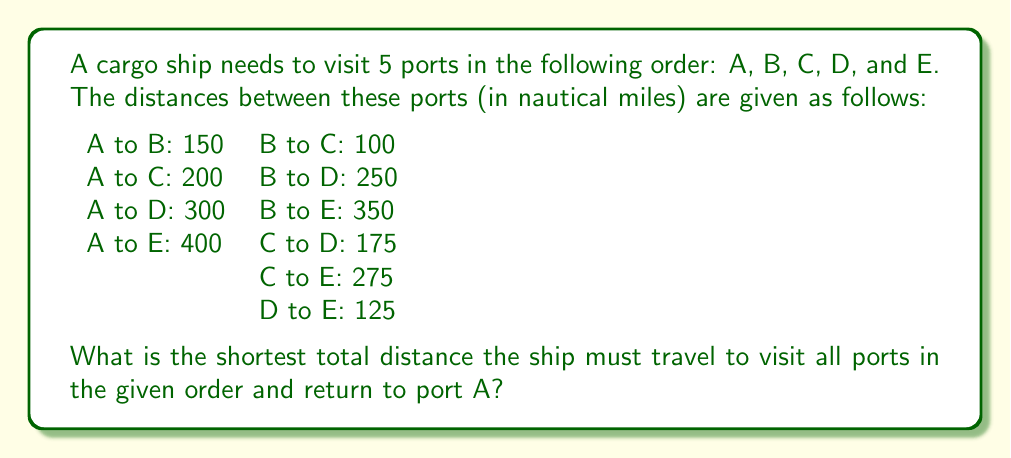Could you help me with this problem? To solve this problem, we need to calculate the total distance of the path A → B → C → D → E → A. Let's break it down step-by-step:

1. Distance from A to B: 150 nautical miles
2. Distance from B to C: 100 nautical miles
3. Distance from C to D: 175 nautical miles
4. Distance from D to E: 125 nautical miles
5. Distance from E back to A: 400 nautical miles

Now, let's sum up these distances:

$$\text{Total Distance} = AB + BC + CD + DE + EA$$
$$\text{Total Distance} = 150 + 100 + 175 + 125 + 400$$
$$\text{Total Distance} = 950 \text{ nautical miles}$$

This problem is a simplified version of the Traveling Salesman Problem, which is a well-known problem in combinatorial optimization. In this case, the order of visiting the ports is predetermined, making it a straightforward calculation rather than an optimization problem.

It's worth noting that in real-world scenarios, factors such as ocean currents, weather conditions, and navigational hazards would also need to be considered when planning the most efficient route. These factors could potentially make a longer route more favorable in terms of fuel efficiency or safety.
Answer: The shortest total distance the ship must travel to visit all ports in the given order and return to port A is 950 nautical miles. 